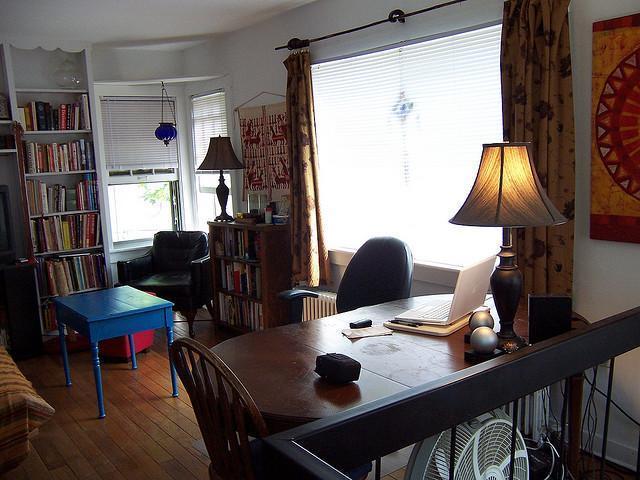How many lamps are turned on in the room?
Give a very brief answer. 1. How many plants are by the window?
Give a very brief answer. 0. How many chairs are in the picture?
Give a very brief answer. 3. How many yellow car in the road?
Give a very brief answer. 0. 